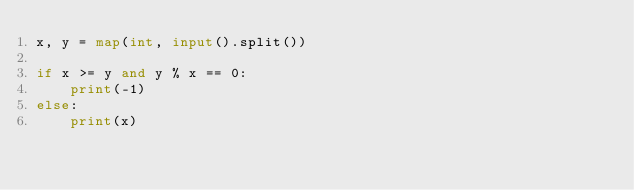Convert code to text. <code><loc_0><loc_0><loc_500><loc_500><_Python_>x, y = map(int, input().split())

if x >= y and y % x == 0:
    print(-1)
else:
    print(x)

</code> 